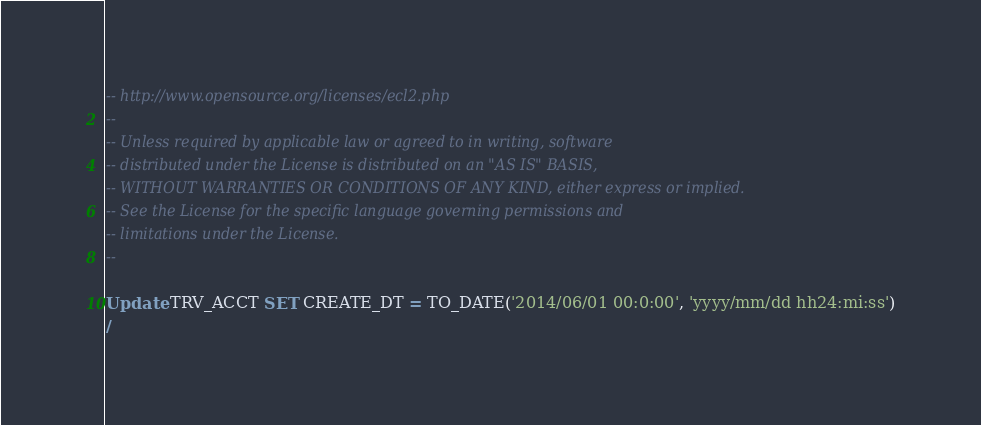<code> <loc_0><loc_0><loc_500><loc_500><_SQL_>-- http://www.opensource.org/licenses/ecl2.php
--
-- Unless required by applicable law or agreed to in writing, software
-- distributed under the License is distributed on an "AS IS" BASIS,
-- WITHOUT WARRANTIES OR CONDITIONS OF ANY KIND, either express or implied.
-- See the License for the specific language governing permissions and
-- limitations under the License.
--

Update TRV_ACCT SET CREATE_DT = TO_DATE('2014/06/01 00:0:00', 'yyyy/mm/dd hh24:mi:ss')
/</code> 